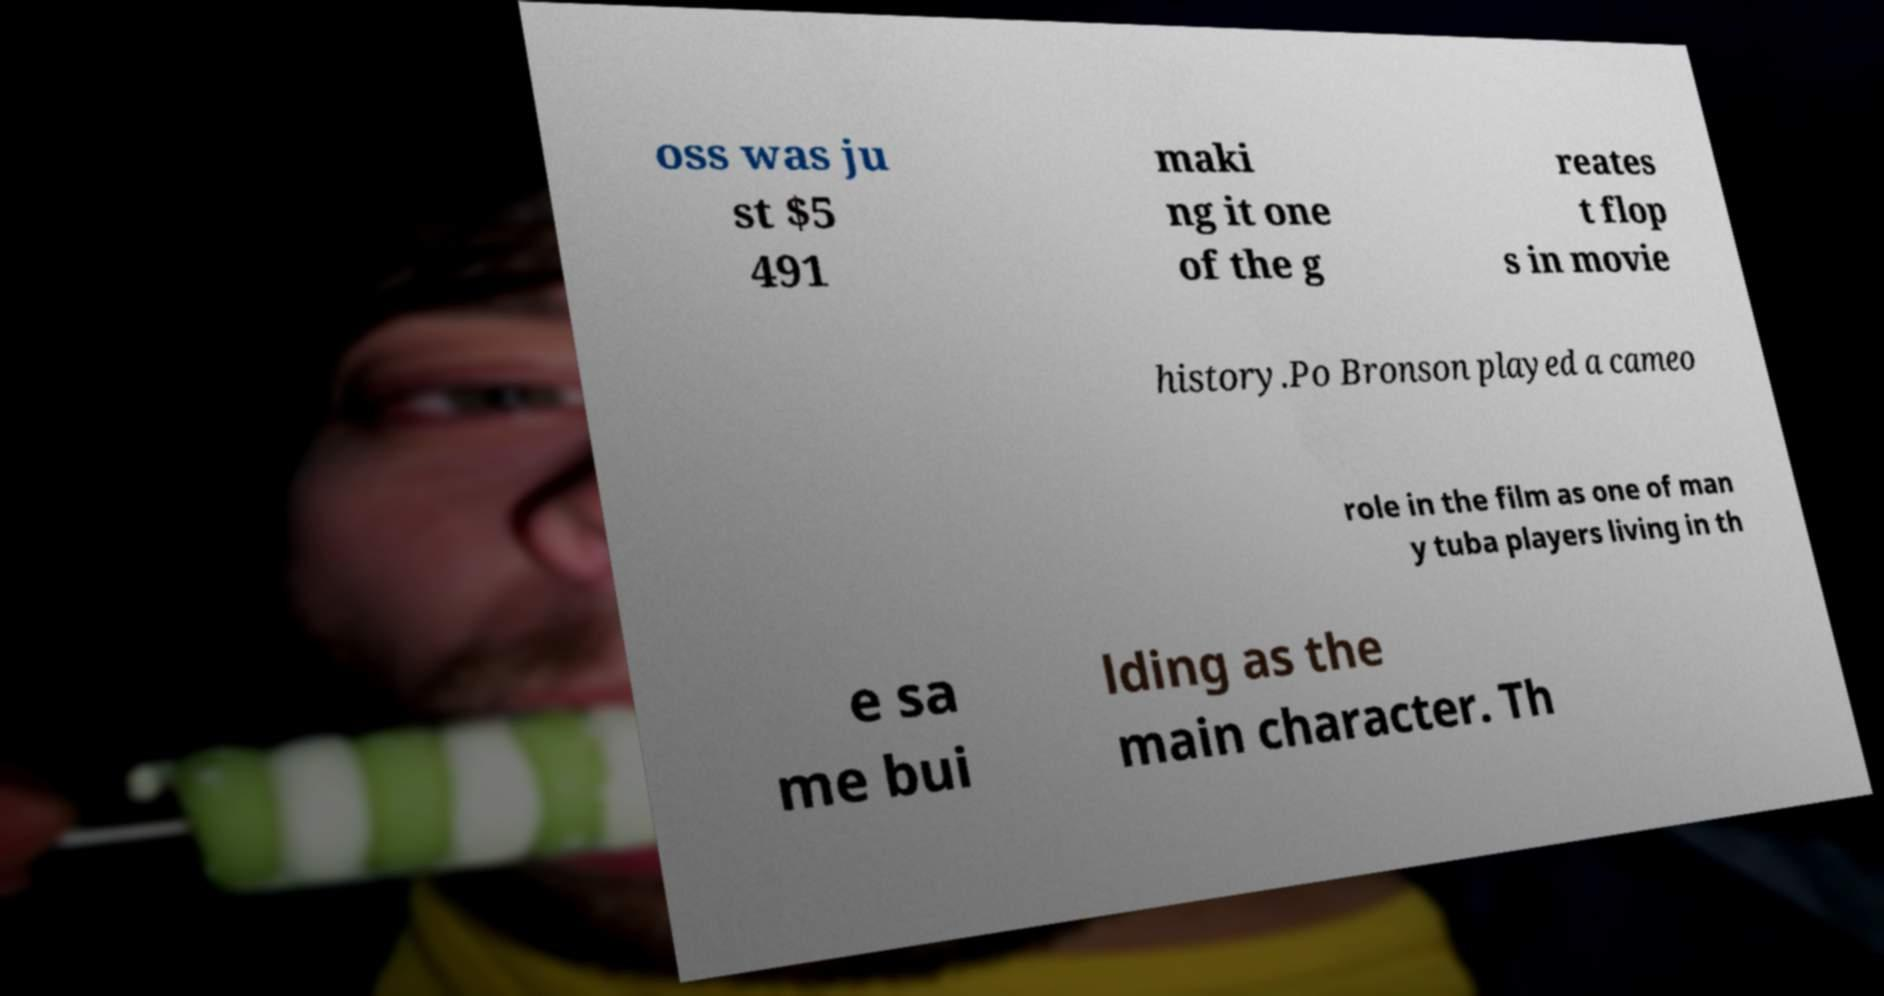What messages or text are displayed in this image? I need them in a readable, typed format. oss was ju st $5 491 maki ng it one of the g reates t flop s in movie history.Po Bronson played a cameo role in the film as one of man y tuba players living in th e sa me bui lding as the main character. Th 